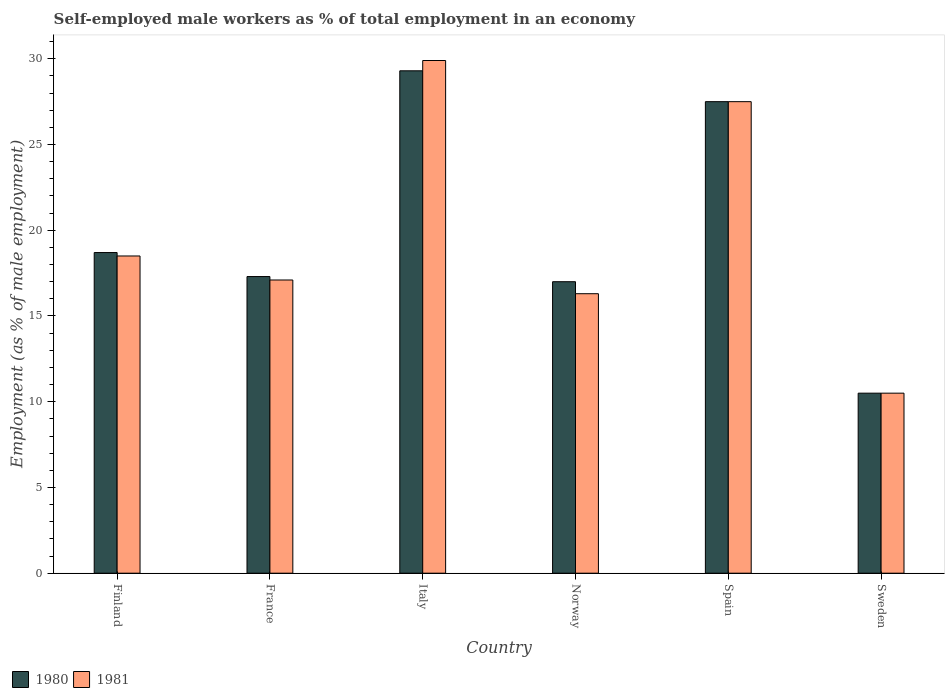Are the number of bars per tick equal to the number of legend labels?
Your response must be concise. Yes. Are the number of bars on each tick of the X-axis equal?
Your answer should be compact. Yes. How many bars are there on the 6th tick from the left?
Give a very brief answer. 2. In how many cases, is the number of bars for a given country not equal to the number of legend labels?
Offer a terse response. 0. What is the percentage of self-employed male workers in 1981 in Sweden?
Your response must be concise. 10.5. Across all countries, what is the maximum percentage of self-employed male workers in 1981?
Your answer should be compact. 29.9. What is the total percentage of self-employed male workers in 1980 in the graph?
Your answer should be very brief. 120.3. What is the difference between the percentage of self-employed male workers in 1980 in Finland and that in Norway?
Offer a very short reply. 1.7. What is the difference between the percentage of self-employed male workers in 1980 in Norway and the percentage of self-employed male workers in 1981 in Italy?
Offer a very short reply. -12.9. What is the average percentage of self-employed male workers in 1981 per country?
Keep it short and to the point. 19.97. What is the difference between the percentage of self-employed male workers of/in 1980 and percentage of self-employed male workers of/in 1981 in Spain?
Give a very brief answer. 0. In how many countries, is the percentage of self-employed male workers in 1981 greater than 12 %?
Make the answer very short. 5. What is the ratio of the percentage of self-employed male workers in 1981 in Finland to that in Italy?
Provide a short and direct response. 0.62. Is the percentage of self-employed male workers in 1981 in Finland less than that in Norway?
Your answer should be compact. No. What is the difference between the highest and the second highest percentage of self-employed male workers in 1981?
Provide a short and direct response. -9. What is the difference between the highest and the lowest percentage of self-employed male workers in 1981?
Ensure brevity in your answer.  19.4. What does the 2nd bar from the left in France represents?
Keep it short and to the point. 1981. How many bars are there?
Give a very brief answer. 12. Are all the bars in the graph horizontal?
Ensure brevity in your answer.  No. How many legend labels are there?
Your answer should be very brief. 2. How are the legend labels stacked?
Your response must be concise. Horizontal. What is the title of the graph?
Keep it short and to the point. Self-employed male workers as % of total employment in an economy. Does "1964" appear as one of the legend labels in the graph?
Your answer should be compact. No. What is the label or title of the X-axis?
Keep it short and to the point. Country. What is the label or title of the Y-axis?
Your response must be concise. Employment (as % of male employment). What is the Employment (as % of male employment) of 1980 in Finland?
Offer a very short reply. 18.7. What is the Employment (as % of male employment) of 1980 in France?
Your response must be concise. 17.3. What is the Employment (as % of male employment) of 1981 in France?
Provide a succinct answer. 17.1. What is the Employment (as % of male employment) in 1980 in Italy?
Your answer should be very brief. 29.3. What is the Employment (as % of male employment) in 1981 in Italy?
Make the answer very short. 29.9. What is the Employment (as % of male employment) of 1980 in Norway?
Give a very brief answer. 17. What is the Employment (as % of male employment) in 1981 in Norway?
Provide a short and direct response. 16.3. What is the Employment (as % of male employment) of 1980 in Sweden?
Make the answer very short. 10.5. What is the Employment (as % of male employment) in 1981 in Sweden?
Make the answer very short. 10.5. Across all countries, what is the maximum Employment (as % of male employment) in 1980?
Offer a terse response. 29.3. Across all countries, what is the maximum Employment (as % of male employment) of 1981?
Your response must be concise. 29.9. Across all countries, what is the minimum Employment (as % of male employment) of 1981?
Make the answer very short. 10.5. What is the total Employment (as % of male employment) in 1980 in the graph?
Your response must be concise. 120.3. What is the total Employment (as % of male employment) in 1981 in the graph?
Your answer should be compact. 119.8. What is the difference between the Employment (as % of male employment) of 1980 in Finland and that in France?
Make the answer very short. 1.4. What is the difference between the Employment (as % of male employment) in 1980 in Finland and that in Italy?
Offer a terse response. -10.6. What is the difference between the Employment (as % of male employment) of 1980 in Finland and that in Norway?
Your response must be concise. 1.7. What is the difference between the Employment (as % of male employment) of 1981 in Finland and that in Spain?
Your response must be concise. -9. What is the difference between the Employment (as % of male employment) in 1980 in France and that in Norway?
Keep it short and to the point. 0.3. What is the difference between the Employment (as % of male employment) of 1980 in France and that in Spain?
Provide a short and direct response. -10.2. What is the difference between the Employment (as % of male employment) in 1980 in France and that in Sweden?
Your answer should be very brief. 6.8. What is the difference between the Employment (as % of male employment) of 1981 in Italy and that in Norway?
Offer a very short reply. 13.6. What is the difference between the Employment (as % of male employment) of 1980 in Italy and that in Spain?
Provide a short and direct response. 1.8. What is the difference between the Employment (as % of male employment) of 1981 in Italy and that in Spain?
Provide a succinct answer. 2.4. What is the difference between the Employment (as % of male employment) of 1980 in Norway and that in Sweden?
Give a very brief answer. 6.5. What is the difference between the Employment (as % of male employment) in 1980 in Finland and the Employment (as % of male employment) in 1981 in France?
Your answer should be very brief. 1.6. What is the difference between the Employment (as % of male employment) in 1980 in Finland and the Employment (as % of male employment) in 1981 in Spain?
Provide a succinct answer. -8.8. What is the difference between the Employment (as % of male employment) in 1980 in France and the Employment (as % of male employment) in 1981 in Italy?
Offer a terse response. -12.6. What is the difference between the Employment (as % of male employment) in 1980 in France and the Employment (as % of male employment) in 1981 in Norway?
Give a very brief answer. 1. What is the difference between the Employment (as % of male employment) in 1980 in Italy and the Employment (as % of male employment) in 1981 in Norway?
Make the answer very short. 13. What is the difference between the Employment (as % of male employment) of 1980 in Italy and the Employment (as % of male employment) of 1981 in Spain?
Ensure brevity in your answer.  1.8. What is the difference between the Employment (as % of male employment) of 1980 in Italy and the Employment (as % of male employment) of 1981 in Sweden?
Your response must be concise. 18.8. What is the difference between the Employment (as % of male employment) in 1980 in Norway and the Employment (as % of male employment) in 1981 in Spain?
Your response must be concise. -10.5. What is the difference between the Employment (as % of male employment) of 1980 in Norway and the Employment (as % of male employment) of 1981 in Sweden?
Provide a short and direct response. 6.5. What is the average Employment (as % of male employment) in 1980 per country?
Provide a succinct answer. 20.05. What is the average Employment (as % of male employment) of 1981 per country?
Your answer should be very brief. 19.97. What is the difference between the Employment (as % of male employment) in 1980 and Employment (as % of male employment) in 1981 in France?
Your response must be concise. 0.2. What is the difference between the Employment (as % of male employment) in 1980 and Employment (as % of male employment) in 1981 in Italy?
Offer a terse response. -0.6. What is the difference between the Employment (as % of male employment) in 1980 and Employment (as % of male employment) in 1981 in Spain?
Ensure brevity in your answer.  0. What is the difference between the Employment (as % of male employment) of 1980 and Employment (as % of male employment) of 1981 in Sweden?
Offer a terse response. 0. What is the ratio of the Employment (as % of male employment) in 1980 in Finland to that in France?
Keep it short and to the point. 1.08. What is the ratio of the Employment (as % of male employment) of 1981 in Finland to that in France?
Ensure brevity in your answer.  1.08. What is the ratio of the Employment (as % of male employment) in 1980 in Finland to that in Italy?
Give a very brief answer. 0.64. What is the ratio of the Employment (as % of male employment) of 1981 in Finland to that in Italy?
Ensure brevity in your answer.  0.62. What is the ratio of the Employment (as % of male employment) in 1981 in Finland to that in Norway?
Provide a succinct answer. 1.14. What is the ratio of the Employment (as % of male employment) in 1980 in Finland to that in Spain?
Offer a terse response. 0.68. What is the ratio of the Employment (as % of male employment) of 1981 in Finland to that in Spain?
Provide a short and direct response. 0.67. What is the ratio of the Employment (as % of male employment) of 1980 in Finland to that in Sweden?
Ensure brevity in your answer.  1.78. What is the ratio of the Employment (as % of male employment) of 1981 in Finland to that in Sweden?
Offer a terse response. 1.76. What is the ratio of the Employment (as % of male employment) in 1980 in France to that in Italy?
Make the answer very short. 0.59. What is the ratio of the Employment (as % of male employment) of 1981 in France to that in Italy?
Your answer should be very brief. 0.57. What is the ratio of the Employment (as % of male employment) in 1980 in France to that in Norway?
Offer a terse response. 1.02. What is the ratio of the Employment (as % of male employment) of 1981 in France to that in Norway?
Your response must be concise. 1.05. What is the ratio of the Employment (as % of male employment) in 1980 in France to that in Spain?
Give a very brief answer. 0.63. What is the ratio of the Employment (as % of male employment) of 1981 in France to that in Spain?
Offer a terse response. 0.62. What is the ratio of the Employment (as % of male employment) of 1980 in France to that in Sweden?
Ensure brevity in your answer.  1.65. What is the ratio of the Employment (as % of male employment) of 1981 in France to that in Sweden?
Provide a short and direct response. 1.63. What is the ratio of the Employment (as % of male employment) in 1980 in Italy to that in Norway?
Provide a succinct answer. 1.72. What is the ratio of the Employment (as % of male employment) of 1981 in Italy to that in Norway?
Give a very brief answer. 1.83. What is the ratio of the Employment (as % of male employment) of 1980 in Italy to that in Spain?
Provide a succinct answer. 1.07. What is the ratio of the Employment (as % of male employment) in 1981 in Italy to that in Spain?
Provide a succinct answer. 1.09. What is the ratio of the Employment (as % of male employment) of 1980 in Italy to that in Sweden?
Make the answer very short. 2.79. What is the ratio of the Employment (as % of male employment) of 1981 in Italy to that in Sweden?
Offer a terse response. 2.85. What is the ratio of the Employment (as % of male employment) of 1980 in Norway to that in Spain?
Provide a short and direct response. 0.62. What is the ratio of the Employment (as % of male employment) in 1981 in Norway to that in Spain?
Keep it short and to the point. 0.59. What is the ratio of the Employment (as % of male employment) in 1980 in Norway to that in Sweden?
Your answer should be compact. 1.62. What is the ratio of the Employment (as % of male employment) in 1981 in Norway to that in Sweden?
Provide a short and direct response. 1.55. What is the ratio of the Employment (as % of male employment) of 1980 in Spain to that in Sweden?
Give a very brief answer. 2.62. What is the ratio of the Employment (as % of male employment) of 1981 in Spain to that in Sweden?
Make the answer very short. 2.62. What is the difference between the highest and the lowest Employment (as % of male employment) of 1980?
Your answer should be very brief. 18.8. What is the difference between the highest and the lowest Employment (as % of male employment) of 1981?
Keep it short and to the point. 19.4. 